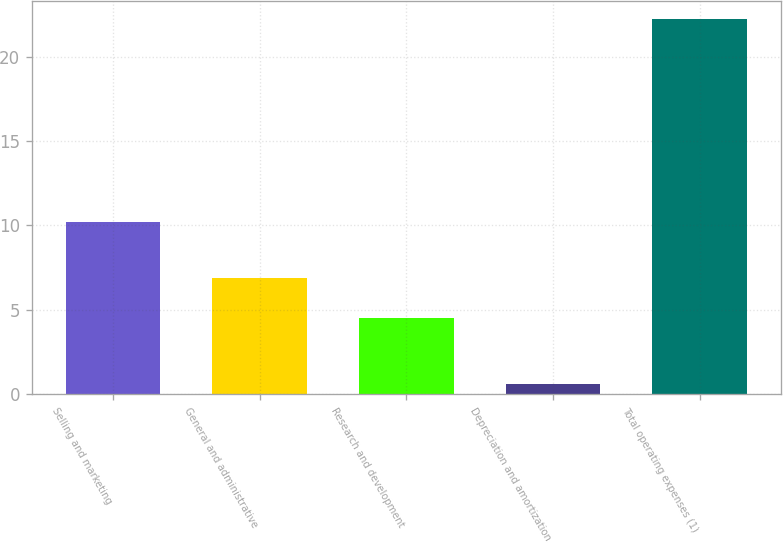<chart> <loc_0><loc_0><loc_500><loc_500><bar_chart><fcel>Selling and marketing<fcel>General and administrative<fcel>Research and development<fcel>Depreciation and amortization<fcel>Total operating expenses (1)<nl><fcel>10.2<fcel>6.9<fcel>4.5<fcel>0.6<fcel>22.2<nl></chart> 